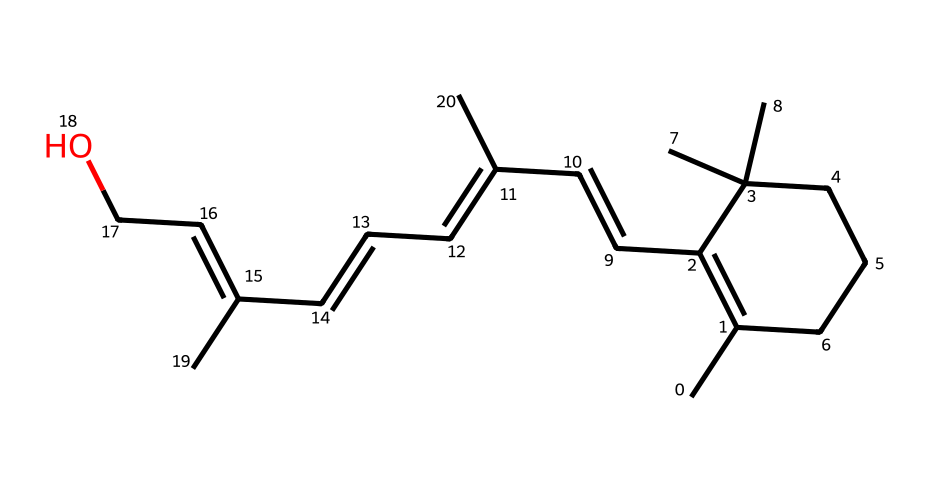What is the molecular formula of vitamin A? By analyzing the SMILES representation, we can count the number of carbon (C), hydrogen (H), and oxygen (O) atoms. The molecular formula for vitamin A corresponds to C20H30O.
Answer: C20H30O How many double bonds are present in the structure? In the provided SMILES representation, we can identify the presence of double bonds by observing the '=' symbols. There are 5 double bonds represented in the structure.
Answer: 5 What functional group is present in vitamin A? When looking at the structure, we see a hydroxyl group (-OH) attached to one of the carbon atoms, which classifies the compound as an alcohol.
Answer: hydroxyl group Is vitamin A soluble in water? Vitamin A, due to its non-polar hydrocarbon components and the presence of a single hydroxyl group, is generally classified as being poorly soluble in water.
Answer: poorly soluble What type of vitamin is vitamin A categorized as? Vitamin A is categorized as a fat-soluble vitamin, which means it is absorbed along with fats in the diet and can be stored in body fat.
Answer: fat-soluble Which part of the molecule aids in its biological function? The conjugated double bond system in the structure allows vitamin A to interact with proteins and enzymes, playing a critical role in vision as well as cell growth and differentiation.
Answer: conjugated double bond system 